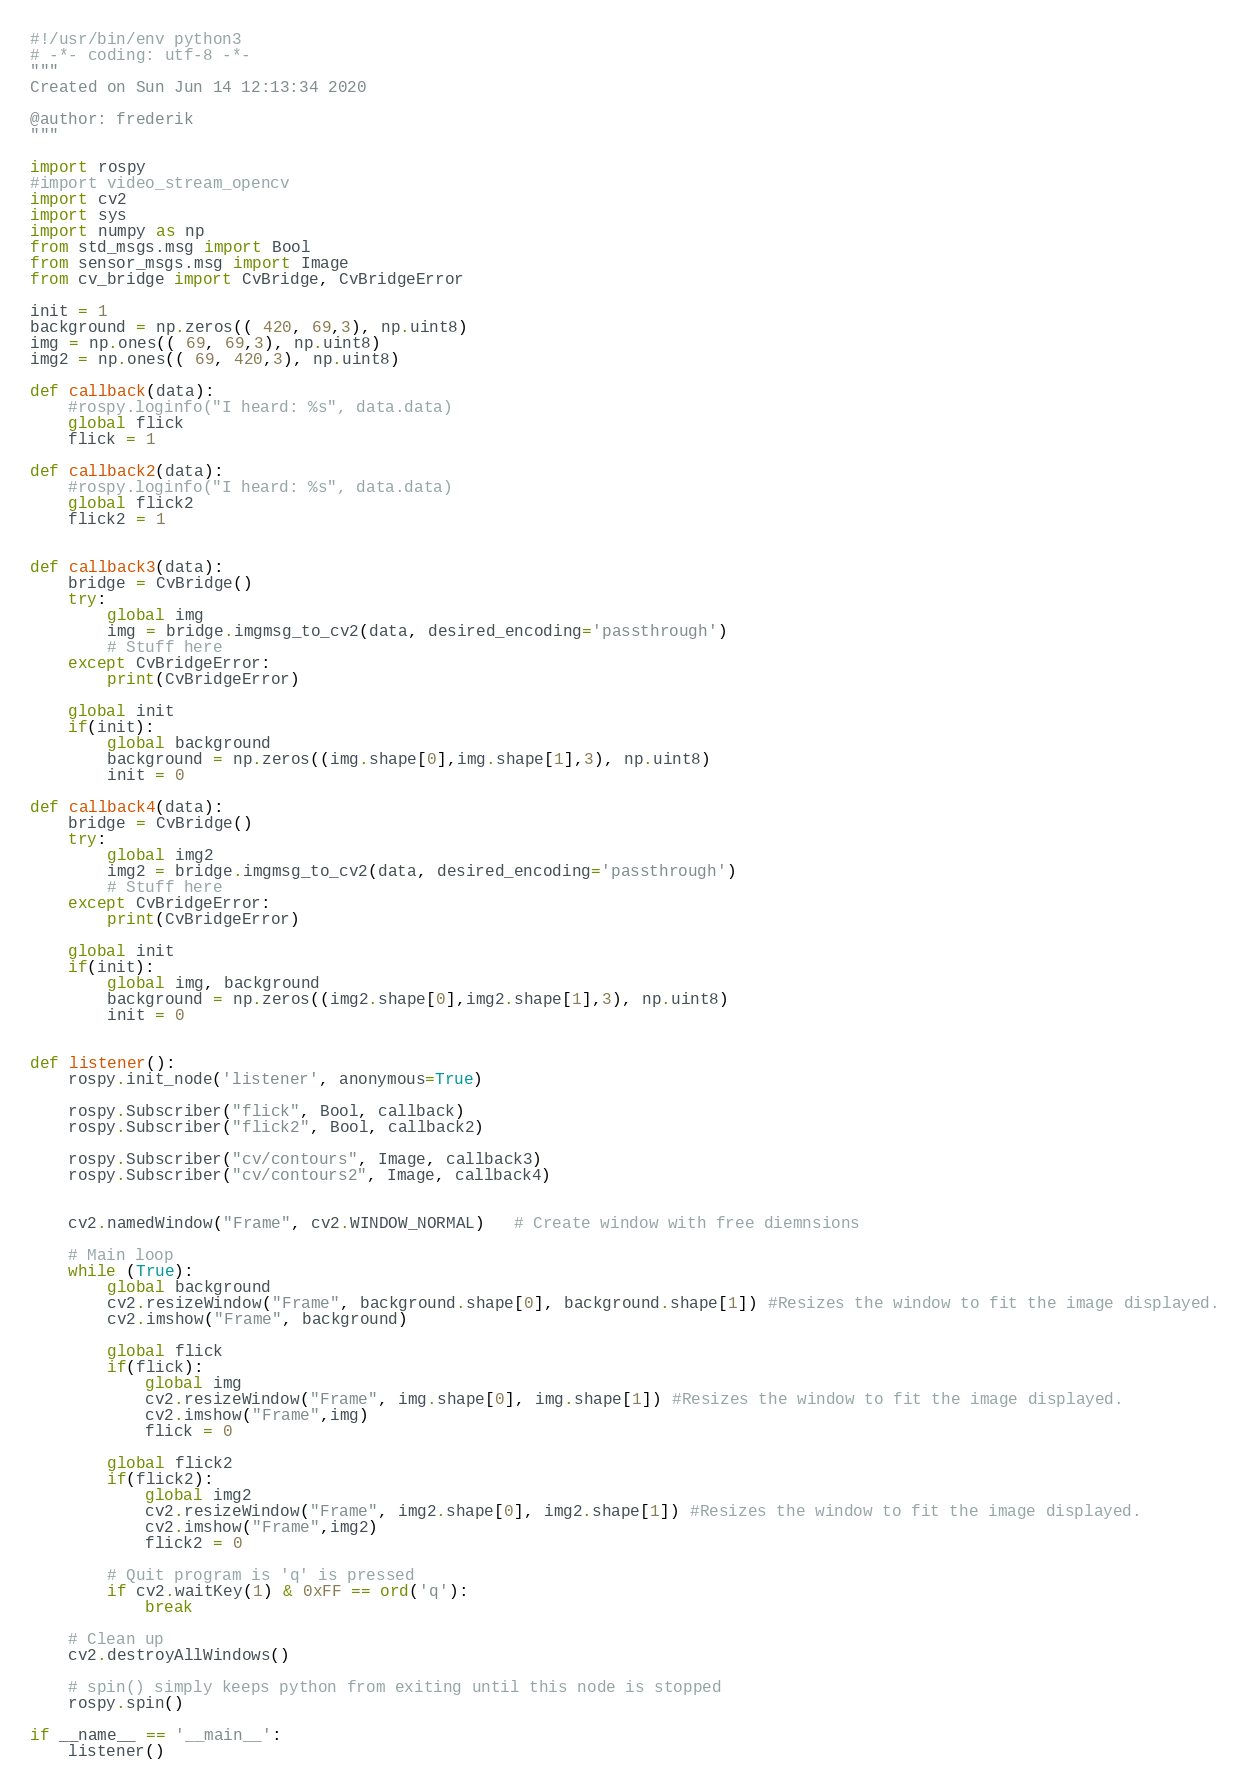<code> <loc_0><loc_0><loc_500><loc_500><_Python_>#!/usr/bin/env python3
# -*- coding: utf-8 -*-
"""
Created on Sun Jun 14 12:13:34 2020

@author: frederik
"""

import rospy
#import video_stream_opencv
import cv2
import sys
import numpy as np
from std_msgs.msg import Bool
from sensor_msgs.msg import Image
from cv_bridge import CvBridge, CvBridgeError

init = 1
background = np.zeros(( 420, 69,3), np.uint8)
img = np.ones(( 69, 69,3), np.uint8)
img2 = np.ones(( 69, 420,3), np.uint8)

def callback(data):
    #rospy.loginfo("I heard: %s", data.data)
    global flick
    flick = 1
    
def callback2(data):
    #rospy.loginfo("I heard: %s", data.data)
    global flick2
    flick2 = 1


def callback3(data):
    bridge = CvBridge()
    try:
        global img
        img = bridge.imgmsg_to_cv2(data, desired_encoding='passthrough')
        # Stuff here
    except CvBridgeError:
        print(CvBridgeError)
        
    global init
    if(init):
        global background
        background = np.zeros((img.shape[0],img.shape[1],3), np.uint8)
        init = 0
        
def callback4(data):
    bridge = CvBridge()
    try:
        global img2
        img2 = bridge.imgmsg_to_cv2(data, desired_encoding='passthrough')
        # Stuff here
    except CvBridgeError:
        print(CvBridgeError)
        
    global init
    if(init):
        global img, background
        background = np.zeros((img2.shape[0],img2.shape[1],3), np.uint8)
        init = 0
    
    
def listener():
    rospy.init_node('listener', anonymous=True)

    rospy.Subscriber("flick", Bool, callback)
    rospy.Subscriber("flick2", Bool, callback2)
    
    rospy.Subscriber("cv/contours", Image, callback3)
    rospy.Subscriber("cv/contours2", Image, callback4)
    
    
    cv2.namedWindow("Frame", cv2.WINDOW_NORMAL)   # Create window with free diemnsions
    
    # Main loop
    while (True):
        global background
        cv2.resizeWindow("Frame", background.shape[0], background.shape[1]) #Resizes the window to fit the image displayed.
        cv2.imshow("Frame", background)
        
        global flick
        if(flick):
            global img
            cv2.resizeWindow("Frame", img.shape[0], img.shape[1]) #Resizes the window to fit the image displayed.
            cv2.imshow("Frame",img)
            flick = 0
            
        global flick2
        if(flick2):
            global img2
            cv2.resizeWindow("Frame", img2.shape[0], img2.shape[1]) #Resizes the window to fit the image displayed.
            cv2.imshow("Frame",img2)
            flick2 = 0
            
        # Quit program is 'q' is pressed
        if cv2.waitKey(1) & 0xFF == ord('q'):
            break
    
    # Clean up
    cv2.destroyAllWindows()
   
    # spin() simply keeps python from exiting until this node is stopped
    rospy.spin()

if __name__ == '__main__':
    listener()

</code> 